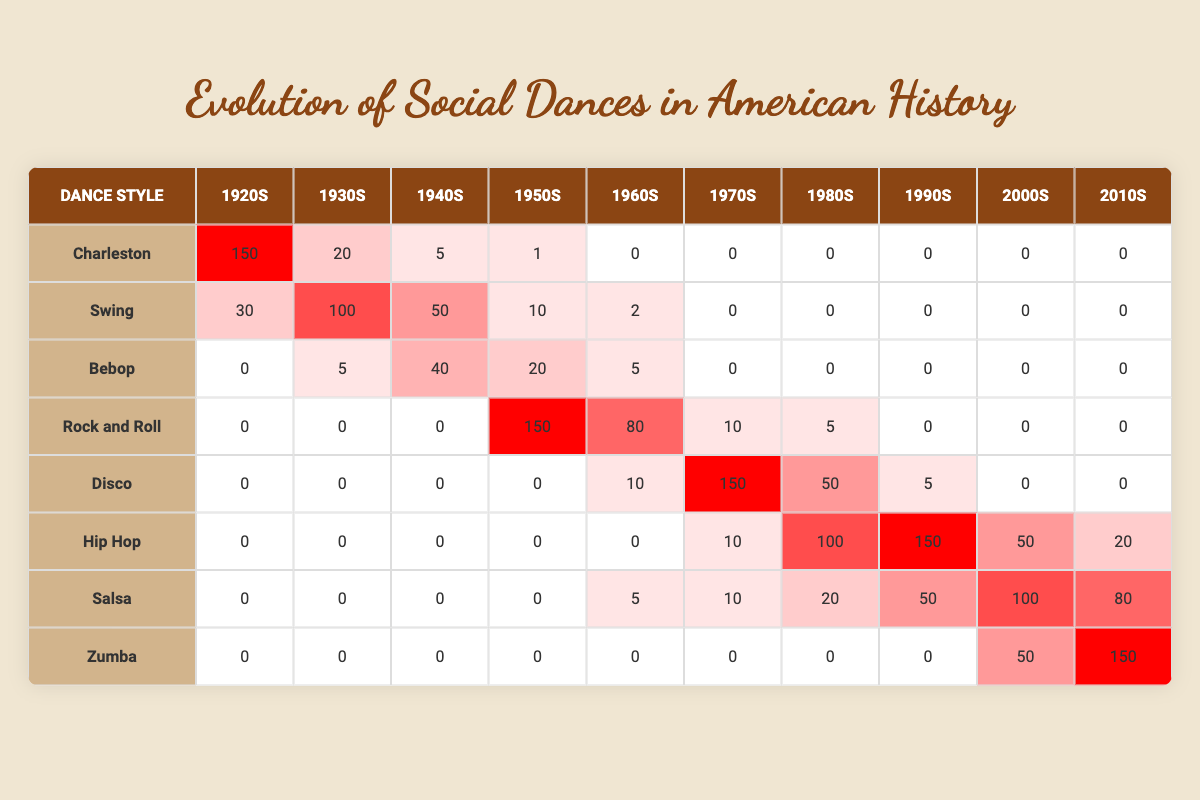What is the most popular dance style in the 1920s? The table shows that the Charleston has the highest value in the 1920s with a count of 150, which is significantly greater than any other dance style during that decade.
Answer: Charleston Which decade saw the peak popularity of Disco? The table indicates that Disco reached its peak popularity in the 1970s with a count of 150, as this is the highest number for that dance style during any decade listed.
Answer: 1970s True or False: Hip Hop was more popular in the 1990s than in the 2000s. By comparing the values in the table, we see that Hip Hop has 150 in the 1990s and 50 in the 2000s, confirming that it was indeed more popular in the 1990s.
Answer: True What is the sum of the counts of Salsa from the 1980s to the 2010s? The counts for Salsa from the 1980s (20), 1990s (50), 2000s (100), and 2010s (80) can be summed up as 20 + 50 + 100 + 80 = 250, which gives us the total for those decades.
Answer: 250 Which dance style consistently had low popularity after the 1950s? The table shows that the Charleston had significantly low popularity after the 1950s, with a count of 0 in all subsequent decades, indicating it did not remain popular.
Answer: Charleston In which decade did Rock and Roll have the greatest decline in popularity? Rock and Roll had its highest count in the 1950s with 150 and then fell to 10 in the 1960s, indicating a sizable decline. The count continues to decline thereafter, reaching 0 by the 2010s.
Answer: 1960s How does the popularity of Zumba in the 2010s compare to its popularity in the 2000s? The counts show Zumba had 50 in the 2000s and increased to 150 in the 2010s. This indicates a rise in popularity in the later decade.
Answer: Increased Which dance style had the highest combined total from the 1920s to the 1940s? To find the combined total for each dance style from the 1920s to the 1940s, we calculate: Charleston (150 + 20 + 5), Swing (30 + 100 + 50), Bebop (0 + 5 + 40). The totals are Charleston: 175, Swing: 180, Bebop: 45. Thus, Swing has the highest total at 180.
Answer: Swing 